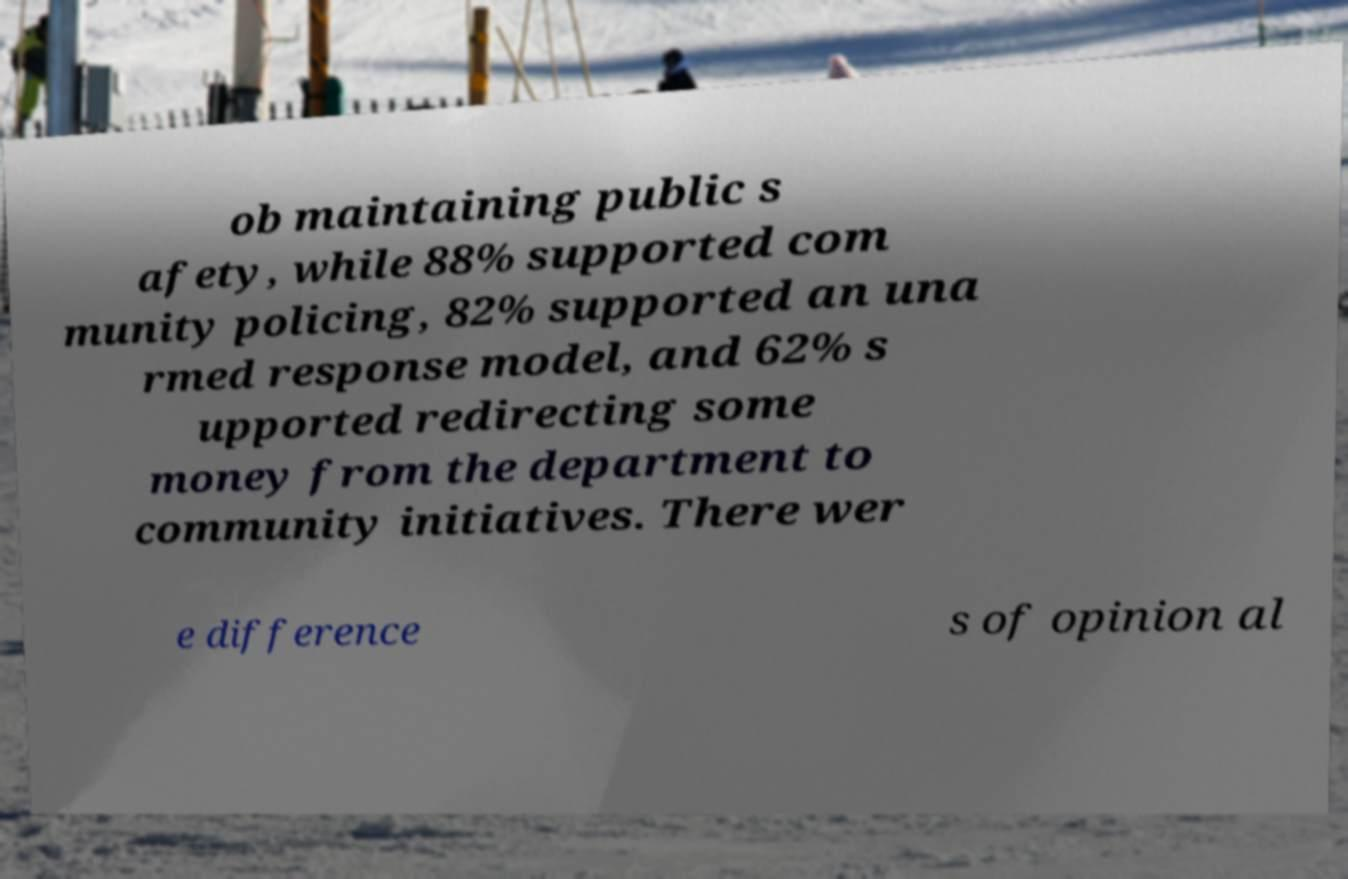Please identify and transcribe the text found in this image. ob maintaining public s afety, while 88% supported com munity policing, 82% supported an una rmed response model, and 62% s upported redirecting some money from the department to community initiatives. There wer e difference s of opinion al 